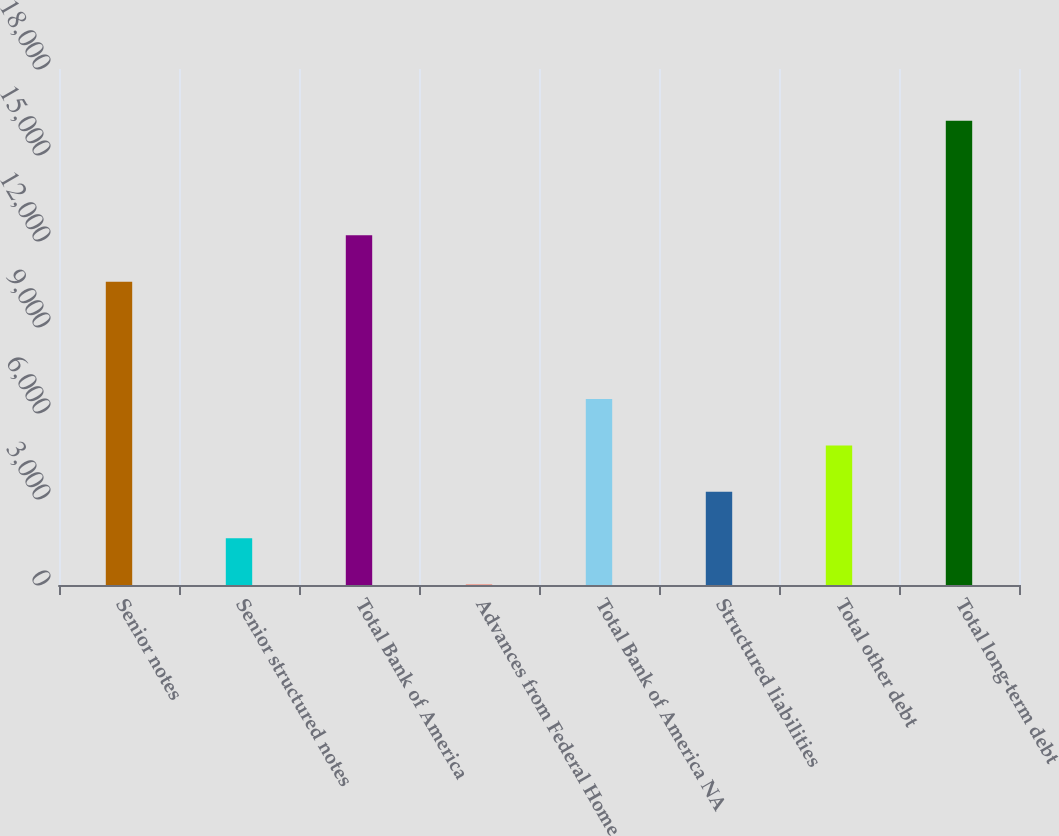<chart> <loc_0><loc_0><loc_500><loc_500><bar_chart><fcel>Senior notes<fcel>Senior structured notes<fcel>Total Bank of America<fcel>Advances from Federal Home<fcel>Total Bank of America NA<fcel>Structured liabilities<fcel>Total other debt<fcel>Total long-term debt<nl><fcel>10580<fcel>1629.8<fcel>12198.8<fcel>11<fcel>6486.2<fcel>3248.6<fcel>4867.4<fcel>16199<nl></chart> 